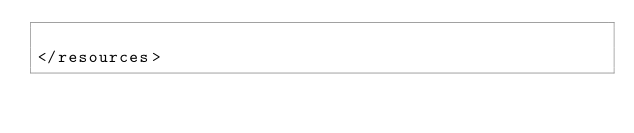Convert code to text. <code><loc_0><loc_0><loc_500><loc_500><_XML_>
</resources></code> 